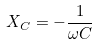Convert formula to latex. <formula><loc_0><loc_0><loc_500><loc_500>X _ { C } = - \frac { 1 } { \omega C }</formula> 